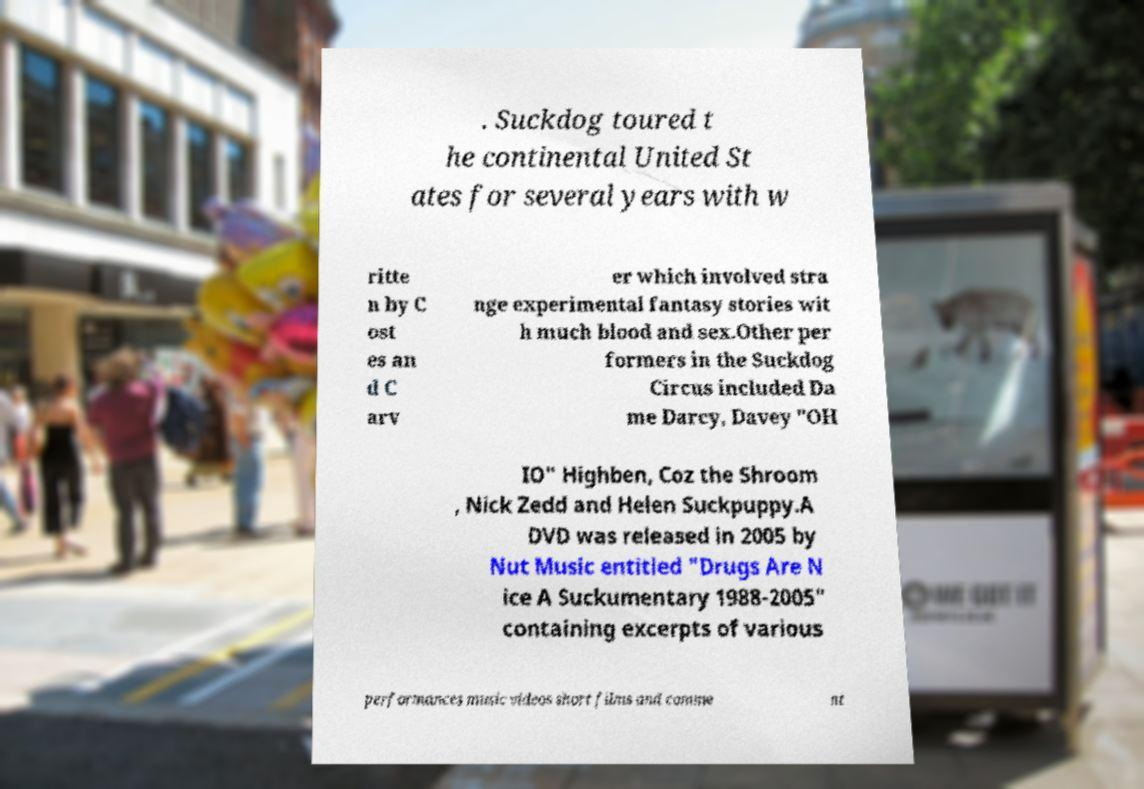Please read and relay the text visible in this image. What does it say? . Suckdog toured t he continental United St ates for several years with w ritte n by C ost es an d C arv er which involved stra nge experimental fantasy stories wit h much blood and sex.Other per formers in the Suckdog Circus included Da me Darcy, Davey "OH IO" Highben, Coz the Shroom , Nick Zedd and Helen Suckpuppy.A DVD was released in 2005 by Nut Music entitled "Drugs Are N ice A Suckumentary 1988-2005" containing excerpts of various performances music videos short films and comme nt 